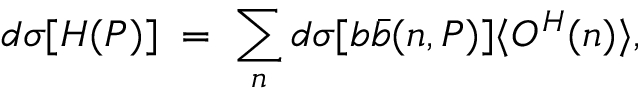Convert formula to latex. <formula><loc_0><loc_0><loc_500><loc_500>d \sigma [ H ( P ) ] \, = \, \sum _ { n } d \sigma [ b \bar { b } ( n , P ) ] \langle O ^ { H } ( n ) \rangle ,</formula> 